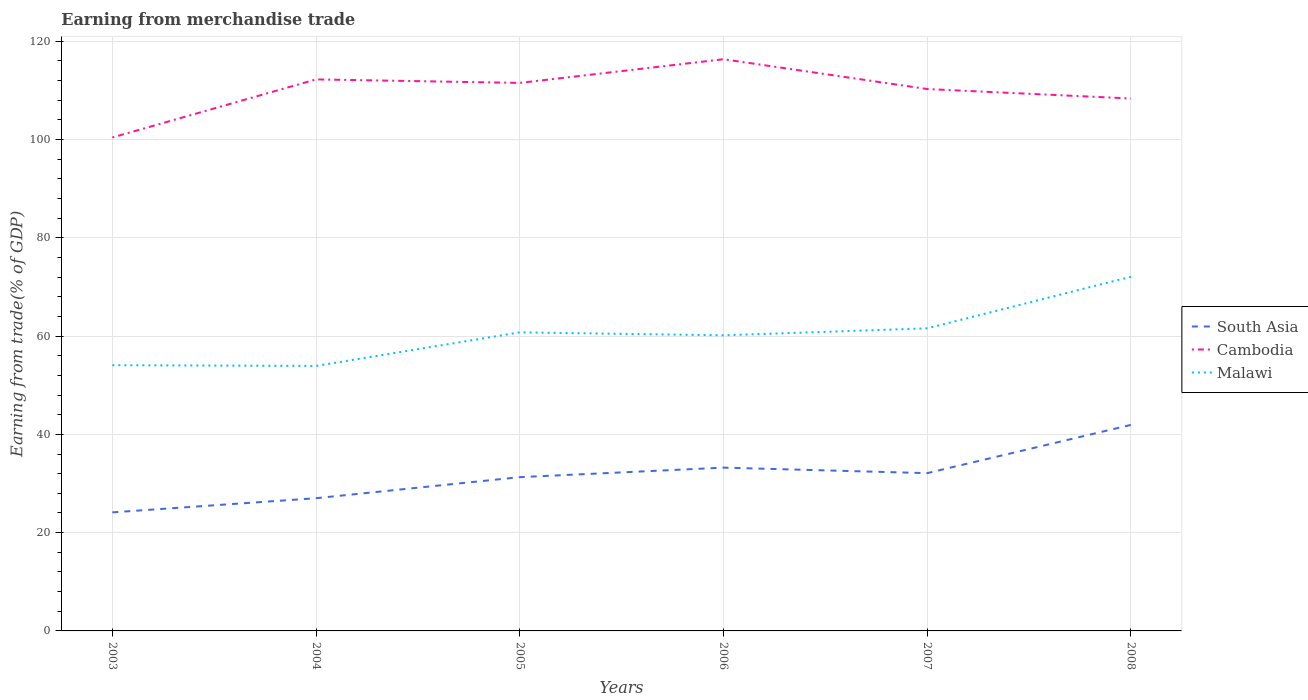How many different coloured lines are there?
Your response must be concise. 3. Across all years, what is the maximum earnings from trade in South Asia?
Offer a very short reply. 24.13. In which year was the earnings from trade in South Asia maximum?
Your response must be concise. 2003. What is the total earnings from trade in Cambodia in the graph?
Keep it short and to the point. 1.25. What is the difference between the highest and the second highest earnings from trade in South Asia?
Your answer should be compact. 17.8. What is the difference between the highest and the lowest earnings from trade in South Asia?
Offer a terse response. 3. Is the earnings from trade in South Asia strictly greater than the earnings from trade in Malawi over the years?
Keep it short and to the point. Yes. What is the difference between two consecutive major ticks on the Y-axis?
Provide a short and direct response. 20. Where does the legend appear in the graph?
Provide a short and direct response. Center right. What is the title of the graph?
Your answer should be compact. Earning from merchandise trade. Does "Luxembourg" appear as one of the legend labels in the graph?
Offer a very short reply. No. What is the label or title of the Y-axis?
Your answer should be compact. Earning from trade(% of GDP). What is the Earning from trade(% of GDP) in South Asia in 2003?
Ensure brevity in your answer.  24.13. What is the Earning from trade(% of GDP) of Cambodia in 2003?
Your answer should be compact. 100.42. What is the Earning from trade(% of GDP) in Malawi in 2003?
Provide a short and direct response. 54.07. What is the Earning from trade(% of GDP) in South Asia in 2004?
Offer a very short reply. 27.01. What is the Earning from trade(% of GDP) of Cambodia in 2004?
Your response must be concise. 112.24. What is the Earning from trade(% of GDP) of Malawi in 2004?
Provide a succinct answer. 53.93. What is the Earning from trade(% of GDP) in South Asia in 2005?
Ensure brevity in your answer.  31.29. What is the Earning from trade(% of GDP) of Cambodia in 2005?
Keep it short and to the point. 111.53. What is the Earning from trade(% of GDP) in Malawi in 2005?
Keep it short and to the point. 60.76. What is the Earning from trade(% of GDP) in South Asia in 2006?
Give a very brief answer. 33.23. What is the Earning from trade(% of GDP) in Cambodia in 2006?
Give a very brief answer. 116.34. What is the Earning from trade(% of GDP) in Malawi in 2006?
Your answer should be compact. 60.16. What is the Earning from trade(% of GDP) of South Asia in 2007?
Provide a succinct answer. 32.11. What is the Earning from trade(% of GDP) in Cambodia in 2007?
Give a very brief answer. 110.28. What is the Earning from trade(% of GDP) in Malawi in 2007?
Ensure brevity in your answer.  61.58. What is the Earning from trade(% of GDP) in South Asia in 2008?
Keep it short and to the point. 41.93. What is the Earning from trade(% of GDP) in Cambodia in 2008?
Provide a succinct answer. 108.35. What is the Earning from trade(% of GDP) in Malawi in 2008?
Your answer should be very brief. 72.08. Across all years, what is the maximum Earning from trade(% of GDP) of South Asia?
Offer a very short reply. 41.93. Across all years, what is the maximum Earning from trade(% of GDP) of Cambodia?
Your response must be concise. 116.34. Across all years, what is the maximum Earning from trade(% of GDP) in Malawi?
Your answer should be very brief. 72.08. Across all years, what is the minimum Earning from trade(% of GDP) of South Asia?
Give a very brief answer. 24.13. Across all years, what is the minimum Earning from trade(% of GDP) in Cambodia?
Ensure brevity in your answer.  100.42. Across all years, what is the minimum Earning from trade(% of GDP) in Malawi?
Your answer should be very brief. 53.93. What is the total Earning from trade(% of GDP) of South Asia in the graph?
Give a very brief answer. 189.7. What is the total Earning from trade(% of GDP) of Cambodia in the graph?
Give a very brief answer. 659.17. What is the total Earning from trade(% of GDP) of Malawi in the graph?
Provide a succinct answer. 362.59. What is the difference between the Earning from trade(% of GDP) of South Asia in 2003 and that in 2004?
Provide a short and direct response. -2.88. What is the difference between the Earning from trade(% of GDP) of Cambodia in 2003 and that in 2004?
Your answer should be very brief. -11.82. What is the difference between the Earning from trade(% of GDP) in Malawi in 2003 and that in 2004?
Ensure brevity in your answer.  0.14. What is the difference between the Earning from trade(% of GDP) in South Asia in 2003 and that in 2005?
Make the answer very short. -7.17. What is the difference between the Earning from trade(% of GDP) of Cambodia in 2003 and that in 2005?
Provide a succinct answer. -11.11. What is the difference between the Earning from trade(% of GDP) of Malawi in 2003 and that in 2005?
Your answer should be very brief. -6.69. What is the difference between the Earning from trade(% of GDP) in South Asia in 2003 and that in 2006?
Offer a terse response. -9.11. What is the difference between the Earning from trade(% of GDP) of Cambodia in 2003 and that in 2006?
Offer a very short reply. -15.92. What is the difference between the Earning from trade(% of GDP) in Malawi in 2003 and that in 2006?
Your response must be concise. -6.09. What is the difference between the Earning from trade(% of GDP) in South Asia in 2003 and that in 2007?
Ensure brevity in your answer.  -7.98. What is the difference between the Earning from trade(% of GDP) of Cambodia in 2003 and that in 2007?
Give a very brief answer. -9.86. What is the difference between the Earning from trade(% of GDP) of Malawi in 2003 and that in 2007?
Your answer should be compact. -7.51. What is the difference between the Earning from trade(% of GDP) of South Asia in 2003 and that in 2008?
Provide a succinct answer. -17.8. What is the difference between the Earning from trade(% of GDP) in Cambodia in 2003 and that in 2008?
Make the answer very short. -7.93. What is the difference between the Earning from trade(% of GDP) in Malawi in 2003 and that in 2008?
Offer a very short reply. -18.01. What is the difference between the Earning from trade(% of GDP) of South Asia in 2004 and that in 2005?
Your answer should be compact. -4.28. What is the difference between the Earning from trade(% of GDP) in Cambodia in 2004 and that in 2005?
Ensure brevity in your answer.  0.71. What is the difference between the Earning from trade(% of GDP) in Malawi in 2004 and that in 2005?
Ensure brevity in your answer.  -6.83. What is the difference between the Earning from trade(% of GDP) of South Asia in 2004 and that in 2006?
Make the answer very short. -6.22. What is the difference between the Earning from trade(% of GDP) of Cambodia in 2004 and that in 2006?
Your answer should be very brief. -4.1. What is the difference between the Earning from trade(% of GDP) of Malawi in 2004 and that in 2006?
Give a very brief answer. -6.23. What is the difference between the Earning from trade(% of GDP) of South Asia in 2004 and that in 2007?
Keep it short and to the point. -5.1. What is the difference between the Earning from trade(% of GDP) of Cambodia in 2004 and that in 2007?
Ensure brevity in your answer.  1.96. What is the difference between the Earning from trade(% of GDP) of Malawi in 2004 and that in 2007?
Provide a short and direct response. -7.65. What is the difference between the Earning from trade(% of GDP) in South Asia in 2004 and that in 2008?
Offer a very short reply. -14.92. What is the difference between the Earning from trade(% of GDP) of Cambodia in 2004 and that in 2008?
Your response must be concise. 3.89. What is the difference between the Earning from trade(% of GDP) in Malawi in 2004 and that in 2008?
Offer a terse response. -18.15. What is the difference between the Earning from trade(% of GDP) of South Asia in 2005 and that in 2006?
Offer a terse response. -1.94. What is the difference between the Earning from trade(% of GDP) in Cambodia in 2005 and that in 2006?
Provide a succinct answer. -4.82. What is the difference between the Earning from trade(% of GDP) in Malawi in 2005 and that in 2006?
Keep it short and to the point. 0.6. What is the difference between the Earning from trade(% of GDP) in South Asia in 2005 and that in 2007?
Offer a very short reply. -0.81. What is the difference between the Earning from trade(% of GDP) in Cambodia in 2005 and that in 2007?
Ensure brevity in your answer.  1.25. What is the difference between the Earning from trade(% of GDP) in Malawi in 2005 and that in 2007?
Provide a short and direct response. -0.82. What is the difference between the Earning from trade(% of GDP) of South Asia in 2005 and that in 2008?
Keep it short and to the point. -10.64. What is the difference between the Earning from trade(% of GDP) of Cambodia in 2005 and that in 2008?
Ensure brevity in your answer.  3.18. What is the difference between the Earning from trade(% of GDP) of Malawi in 2005 and that in 2008?
Provide a short and direct response. -11.32. What is the difference between the Earning from trade(% of GDP) of South Asia in 2006 and that in 2007?
Your answer should be very brief. 1.12. What is the difference between the Earning from trade(% of GDP) of Cambodia in 2006 and that in 2007?
Make the answer very short. 6.06. What is the difference between the Earning from trade(% of GDP) in Malawi in 2006 and that in 2007?
Provide a succinct answer. -1.42. What is the difference between the Earning from trade(% of GDP) in South Asia in 2006 and that in 2008?
Your answer should be compact. -8.7. What is the difference between the Earning from trade(% of GDP) of Cambodia in 2006 and that in 2008?
Your response must be concise. 7.99. What is the difference between the Earning from trade(% of GDP) of Malawi in 2006 and that in 2008?
Provide a succinct answer. -11.92. What is the difference between the Earning from trade(% of GDP) in South Asia in 2007 and that in 2008?
Ensure brevity in your answer.  -9.82. What is the difference between the Earning from trade(% of GDP) of Cambodia in 2007 and that in 2008?
Offer a terse response. 1.93. What is the difference between the Earning from trade(% of GDP) of Malawi in 2007 and that in 2008?
Your response must be concise. -10.5. What is the difference between the Earning from trade(% of GDP) of South Asia in 2003 and the Earning from trade(% of GDP) of Cambodia in 2004?
Offer a very short reply. -88.12. What is the difference between the Earning from trade(% of GDP) in South Asia in 2003 and the Earning from trade(% of GDP) in Malawi in 2004?
Give a very brief answer. -29.8. What is the difference between the Earning from trade(% of GDP) of Cambodia in 2003 and the Earning from trade(% of GDP) of Malawi in 2004?
Your response must be concise. 46.49. What is the difference between the Earning from trade(% of GDP) of South Asia in 2003 and the Earning from trade(% of GDP) of Cambodia in 2005?
Give a very brief answer. -87.4. What is the difference between the Earning from trade(% of GDP) in South Asia in 2003 and the Earning from trade(% of GDP) in Malawi in 2005?
Provide a short and direct response. -36.64. What is the difference between the Earning from trade(% of GDP) in Cambodia in 2003 and the Earning from trade(% of GDP) in Malawi in 2005?
Your answer should be very brief. 39.66. What is the difference between the Earning from trade(% of GDP) of South Asia in 2003 and the Earning from trade(% of GDP) of Cambodia in 2006?
Offer a very short reply. -92.22. What is the difference between the Earning from trade(% of GDP) in South Asia in 2003 and the Earning from trade(% of GDP) in Malawi in 2006?
Make the answer very short. -36.04. What is the difference between the Earning from trade(% of GDP) of Cambodia in 2003 and the Earning from trade(% of GDP) of Malawi in 2006?
Give a very brief answer. 40.26. What is the difference between the Earning from trade(% of GDP) in South Asia in 2003 and the Earning from trade(% of GDP) in Cambodia in 2007?
Offer a very short reply. -86.15. What is the difference between the Earning from trade(% of GDP) in South Asia in 2003 and the Earning from trade(% of GDP) in Malawi in 2007?
Give a very brief answer. -37.46. What is the difference between the Earning from trade(% of GDP) of Cambodia in 2003 and the Earning from trade(% of GDP) of Malawi in 2007?
Ensure brevity in your answer.  38.84. What is the difference between the Earning from trade(% of GDP) in South Asia in 2003 and the Earning from trade(% of GDP) in Cambodia in 2008?
Your answer should be compact. -84.22. What is the difference between the Earning from trade(% of GDP) in South Asia in 2003 and the Earning from trade(% of GDP) in Malawi in 2008?
Give a very brief answer. -47.95. What is the difference between the Earning from trade(% of GDP) of Cambodia in 2003 and the Earning from trade(% of GDP) of Malawi in 2008?
Make the answer very short. 28.34. What is the difference between the Earning from trade(% of GDP) in South Asia in 2004 and the Earning from trade(% of GDP) in Cambodia in 2005?
Your answer should be compact. -84.52. What is the difference between the Earning from trade(% of GDP) in South Asia in 2004 and the Earning from trade(% of GDP) in Malawi in 2005?
Your answer should be very brief. -33.75. What is the difference between the Earning from trade(% of GDP) of Cambodia in 2004 and the Earning from trade(% of GDP) of Malawi in 2005?
Provide a succinct answer. 51.48. What is the difference between the Earning from trade(% of GDP) in South Asia in 2004 and the Earning from trade(% of GDP) in Cambodia in 2006?
Provide a short and direct response. -89.34. What is the difference between the Earning from trade(% of GDP) in South Asia in 2004 and the Earning from trade(% of GDP) in Malawi in 2006?
Provide a succinct answer. -33.15. What is the difference between the Earning from trade(% of GDP) in Cambodia in 2004 and the Earning from trade(% of GDP) in Malawi in 2006?
Your answer should be very brief. 52.08. What is the difference between the Earning from trade(% of GDP) of South Asia in 2004 and the Earning from trade(% of GDP) of Cambodia in 2007?
Provide a succinct answer. -83.27. What is the difference between the Earning from trade(% of GDP) in South Asia in 2004 and the Earning from trade(% of GDP) in Malawi in 2007?
Offer a terse response. -34.57. What is the difference between the Earning from trade(% of GDP) of Cambodia in 2004 and the Earning from trade(% of GDP) of Malawi in 2007?
Provide a succinct answer. 50.66. What is the difference between the Earning from trade(% of GDP) in South Asia in 2004 and the Earning from trade(% of GDP) in Cambodia in 2008?
Offer a terse response. -81.34. What is the difference between the Earning from trade(% of GDP) of South Asia in 2004 and the Earning from trade(% of GDP) of Malawi in 2008?
Provide a succinct answer. -45.07. What is the difference between the Earning from trade(% of GDP) in Cambodia in 2004 and the Earning from trade(% of GDP) in Malawi in 2008?
Ensure brevity in your answer.  40.16. What is the difference between the Earning from trade(% of GDP) of South Asia in 2005 and the Earning from trade(% of GDP) of Cambodia in 2006?
Ensure brevity in your answer.  -85.05. What is the difference between the Earning from trade(% of GDP) of South Asia in 2005 and the Earning from trade(% of GDP) of Malawi in 2006?
Your answer should be compact. -28.87. What is the difference between the Earning from trade(% of GDP) in Cambodia in 2005 and the Earning from trade(% of GDP) in Malawi in 2006?
Offer a very short reply. 51.37. What is the difference between the Earning from trade(% of GDP) in South Asia in 2005 and the Earning from trade(% of GDP) in Cambodia in 2007?
Your answer should be compact. -78.99. What is the difference between the Earning from trade(% of GDP) in South Asia in 2005 and the Earning from trade(% of GDP) in Malawi in 2007?
Your answer should be very brief. -30.29. What is the difference between the Earning from trade(% of GDP) in Cambodia in 2005 and the Earning from trade(% of GDP) in Malawi in 2007?
Your response must be concise. 49.95. What is the difference between the Earning from trade(% of GDP) of South Asia in 2005 and the Earning from trade(% of GDP) of Cambodia in 2008?
Your response must be concise. -77.06. What is the difference between the Earning from trade(% of GDP) in South Asia in 2005 and the Earning from trade(% of GDP) in Malawi in 2008?
Keep it short and to the point. -40.79. What is the difference between the Earning from trade(% of GDP) of Cambodia in 2005 and the Earning from trade(% of GDP) of Malawi in 2008?
Give a very brief answer. 39.45. What is the difference between the Earning from trade(% of GDP) of South Asia in 2006 and the Earning from trade(% of GDP) of Cambodia in 2007?
Provide a succinct answer. -77.05. What is the difference between the Earning from trade(% of GDP) of South Asia in 2006 and the Earning from trade(% of GDP) of Malawi in 2007?
Provide a short and direct response. -28.35. What is the difference between the Earning from trade(% of GDP) in Cambodia in 2006 and the Earning from trade(% of GDP) in Malawi in 2007?
Offer a very short reply. 54.76. What is the difference between the Earning from trade(% of GDP) of South Asia in 2006 and the Earning from trade(% of GDP) of Cambodia in 2008?
Make the answer very short. -75.12. What is the difference between the Earning from trade(% of GDP) of South Asia in 2006 and the Earning from trade(% of GDP) of Malawi in 2008?
Provide a succinct answer. -38.85. What is the difference between the Earning from trade(% of GDP) in Cambodia in 2006 and the Earning from trade(% of GDP) in Malawi in 2008?
Offer a terse response. 44.27. What is the difference between the Earning from trade(% of GDP) of South Asia in 2007 and the Earning from trade(% of GDP) of Cambodia in 2008?
Make the answer very short. -76.24. What is the difference between the Earning from trade(% of GDP) in South Asia in 2007 and the Earning from trade(% of GDP) in Malawi in 2008?
Provide a succinct answer. -39.97. What is the difference between the Earning from trade(% of GDP) in Cambodia in 2007 and the Earning from trade(% of GDP) in Malawi in 2008?
Ensure brevity in your answer.  38.2. What is the average Earning from trade(% of GDP) of South Asia per year?
Keep it short and to the point. 31.62. What is the average Earning from trade(% of GDP) of Cambodia per year?
Give a very brief answer. 109.86. What is the average Earning from trade(% of GDP) in Malawi per year?
Offer a terse response. 60.43. In the year 2003, what is the difference between the Earning from trade(% of GDP) of South Asia and Earning from trade(% of GDP) of Cambodia?
Make the answer very short. -76.3. In the year 2003, what is the difference between the Earning from trade(% of GDP) of South Asia and Earning from trade(% of GDP) of Malawi?
Give a very brief answer. -29.95. In the year 2003, what is the difference between the Earning from trade(% of GDP) in Cambodia and Earning from trade(% of GDP) in Malawi?
Provide a short and direct response. 46.35. In the year 2004, what is the difference between the Earning from trade(% of GDP) of South Asia and Earning from trade(% of GDP) of Cambodia?
Make the answer very short. -85.23. In the year 2004, what is the difference between the Earning from trade(% of GDP) in South Asia and Earning from trade(% of GDP) in Malawi?
Offer a very short reply. -26.92. In the year 2004, what is the difference between the Earning from trade(% of GDP) of Cambodia and Earning from trade(% of GDP) of Malawi?
Make the answer very short. 58.31. In the year 2005, what is the difference between the Earning from trade(% of GDP) of South Asia and Earning from trade(% of GDP) of Cambodia?
Offer a very short reply. -80.23. In the year 2005, what is the difference between the Earning from trade(% of GDP) of South Asia and Earning from trade(% of GDP) of Malawi?
Make the answer very short. -29.47. In the year 2005, what is the difference between the Earning from trade(% of GDP) of Cambodia and Earning from trade(% of GDP) of Malawi?
Your answer should be compact. 50.77. In the year 2006, what is the difference between the Earning from trade(% of GDP) of South Asia and Earning from trade(% of GDP) of Cambodia?
Offer a terse response. -83.11. In the year 2006, what is the difference between the Earning from trade(% of GDP) of South Asia and Earning from trade(% of GDP) of Malawi?
Offer a very short reply. -26.93. In the year 2006, what is the difference between the Earning from trade(% of GDP) in Cambodia and Earning from trade(% of GDP) in Malawi?
Make the answer very short. 56.18. In the year 2007, what is the difference between the Earning from trade(% of GDP) in South Asia and Earning from trade(% of GDP) in Cambodia?
Give a very brief answer. -78.17. In the year 2007, what is the difference between the Earning from trade(% of GDP) in South Asia and Earning from trade(% of GDP) in Malawi?
Give a very brief answer. -29.47. In the year 2007, what is the difference between the Earning from trade(% of GDP) of Cambodia and Earning from trade(% of GDP) of Malawi?
Ensure brevity in your answer.  48.7. In the year 2008, what is the difference between the Earning from trade(% of GDP) of South Asia and Earning from trade(% of GDP) of Cambodia?
Provide a succinct answer. -66.42. In the year 2008, what is the difference between the Earning from trade(% of GDP) in South Asia and Earning from trade(% of GDP) in Malawi?
Your response must be concise. -30.15. In the year 2008, what is the difference between the Earning from trade(% of GDP) in Cambodia and Earning from trade(% of GDP) in Malawi?
Your answer should be compact. 36.27. What is the ratio of the Earning from trade(% of GDP) of South Asia in 2003 to that in 2004?
Keep it short and to the point. 0.89. What is the ratio of the Earning from trade(% of GDP) in Cambodia in 2003 to that in 2004?
Give a very brief answer. 0.89. What is the ratio of the Earning from trade(% of GDP) of Malawi in 2003 to that in 2004?
Give a very brief answer. 1. What is the ratio of the Earning from trade(% of GDP) in South Asia in 2003 to that in 2005?
Your answer should be very brief. 0.77. What is the ratio of the Earning from trade(% of GDP) of Cambodia in 2003 to that in 2005?
Offer a terse response. 0.9. What is the ratio of the Earning from trade(% of GDP) in Malawi in 2003 to that in 2005?
Your answer should be compact. 0.89. What is the ratio of the Earning from trade(% of GDP) of South Asia in 2003 to that in 2006?
Offer a terse response. 0.73. What is the ratio of the Earning from trade(% of GDP) in Cambodia in 2003 to that in 2006?
Offer a terse response. 0.86. What is the ratio of the Earning from trade(% of GDP) in Malawi in 2003 to that in 2006?
Keep it short and to the point. 0.9. What is the ratio of the Earning from trade(% of GDP) of South Asia in 2003 to that in 2007?
Provide a short and direct response. 0.75. What is the ratio of the Earning from trade(% of GDP) of Cambodia in 2003 to that in 2007?
Give a very brief answer. 0.91. What is the ratio of the Earning from trade(% of GDP) of Malawi in 2003 to that in 2007?
Give a very brief answer. 0.88. What is the ratio of the Earning from trade(% of GDP) of South Asia in 2003 to that in 2008?
Your answer should be compact. 0.58. What is the ratio of the Earning from trade(% of GDP) of Cambodia in 2003 to that in 2008?
Make the answer very short. 0.93. What is the ratio of the Earning from trade(% of GDP) in Malawi in 2003 to that in 2008?
Make the answer very short. 0.75. What is the ratio of the Earning from trade(% of GDP) of South Asia in 2004 to that in 2005?
Provide a succinct answer. 0.86. What is the ratio of the Earning from trade(% of GDP) of Cambodia in 2004 to that in 2005?
Keep it short and to the point. 1.01. What is the ratio of the Earning from trade(% of GDP) of Malawi in 2004 to that in 2005?
Make the answer very short. 0.89. What is the ratio of the Earning from trade(% of GDP) in South Asia in 2004 to that in 2006?
Provide a succinct answer. 0.81. What is the ratio of the Earning from trade(% of GDP) of Cambodia in 2004 to that in 2006?
Give a very brief answer. 0.96. What is the ratio of the Earning from trade(% of GDP) of Malawi in 2004 to that in 2006?
Keep it short and to the point. 0.9. What is the ratio of the Earning from trade(% of GDP) in South Asia in 2004 to that in 2007?
Keep it short and to the point. 0.84. What is the ratio of the Earning from trade(% of GDP) of Cambodia in 2004 to that in 2007?
Give a very brief answer. 1.02. What is the ratio of the Earning from trade(% of GDP) in Malawi in 2004 to that in 2007?
Ensure brevity in your answer.  0.88. What is the ratio of the Earning from trade(% of GDP) of South Asia in 2004 to that in 2008?
Your response must be concise. 0.64. What is the ratio of the Earning from trade(% of GDP) of Cambodia in 2004 to that in 2008?
Your answer should be very brief. 1.04. What is the ratio of the Earning from trade(% of GDP) of Malawi in 2004 to that in 2008?
Offer a terse response. 0.75. What is the ratio of the Earning from trade(% of GDP) of South Asia in 2005 to that in 2006?
Keep it short and to the point. 0.94. What is the ratio of the Earning from trade(% of GDP) in Cambodia in 2005 to that in 2006?
Provide a short and direct response. 0.96. What is the ratio of the Earning from trade(% of GDP) of Malawi in 2005 to that in 2006?
Keep it short and to the point. 1.01. What is the ratio of the Earning from trade(% of GDP) of South Asia in 2005 to that in 2007?
Give a very brief answer. 0.97. What is the ratio of the Earning from trade(% of GDP) of Cambodia in 2005 to that in 2007?
Your response must be concise. 1.01. What is the ratio of the Earning from trade(% of GDP) of Malawi in 2005 to that in 2007?
Your response must be concise. 0.99. What is the ratio of the Earning from trade(% of GDP) in South Asia in 2005 to that in 2008?
Offer a very short reply. 0.75. What is the ratio of the Earning from trade(% of GDP) of Cambodia in 2005 to that in 2008?
Provide a short and direct response. 1.03. What is the ratio of the Earning from trade(% of GDP) of Malawi in 2005 to that in 2008?
Ensure brevity in your answer.  0.84. What is the ratio of the Earning from trade(% of GDP) in South Asia in 2006 to that in 2007?
Provide a succinct answer. 1.03. What is the ratio of the Earning from trade(% of GDP) in Cambodia in 2006 to that in 2007?
Give a very brief answer. 1.05. What is the ratio of the Earning from trade(% of GDP) in Malawi in 2006 to that in 2007?
Offer a very short reply. 0.98. What is the ratio of the Earning from trade(% of GDP) in South Asia in 2006 to that in 2008?
Offer a very short reply. 0.79. What is the ratio of the Earning from trade(% of GDP) of Cambodia in 2006 to that in 2008?
Ensure brevity in your answer.  1.07. What is the ratio of the Earning from trade(% of GDP) in Malawi in 2006 to that in 2008?
Make the answer very short. 0.83. What is the ratio of the Earning from trade(% of GDP) in South Asia in 2007 to that in 2008?
Your response must be concise. 0.77. What is the ratio of the Earning from trade(% of GDP) in Cambodia in 2007 to that in 2008?
Ensure brevity in your answer.  1.02. What is the ratio of the Earning from trade(% of GDP) of Malawi in 2007 to that in 2008?
Offer a very short reply. 0.85. What is the difference between the highest and the second highest Earning from trade(% of GDP) of South Asia?
Provide a short and direct response. 8.7. What is the difference between the highest and the second highest Earning from trade(% of GDP) of Cambodia?
Your answer should be very brief. 4.1. What is the difference between the highest and the second highest Earning from trade(% of GDP) of Malawi?
Your response must be concise. 10.5. What is the difference between the highest and the lowest Earning from trade(% of GDP) in South Asia?
Give a very brief answer. 17.8. What is the difference between the highest and the lowest Earning from trade(% of GDP) of Cambodia?
Keep it short and to the point. 15.92. What is the difference between the highest and the lowest Earning from trade(% of GDP) in Malawi?
Make the answer very short. 18.15. 